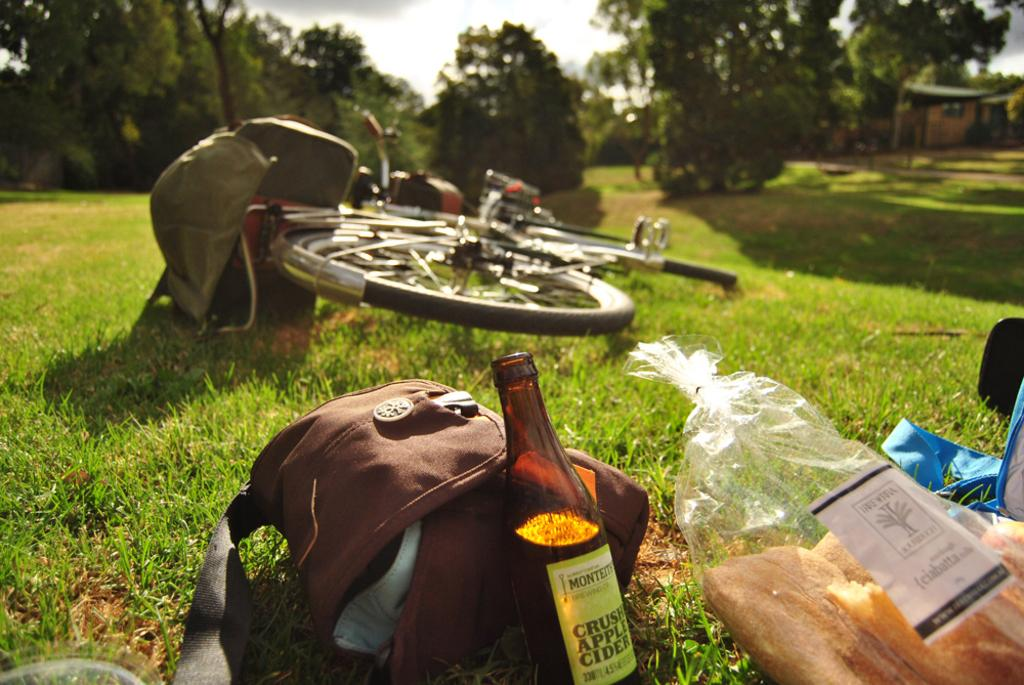What is one of the objects visible in the image? There is a bottle in the image. What else can be seen in the image? There is a bag, a cycle, a cover, and bread visible in the image. Where are these objects located? These objects are on the grass. What can be seen in the background of the image? There are trees and the sky visible in the background of the image. What type of butter is being used to promote health in the image? There is no butter present in the image, and the image does not depict any health-related activities or products. 